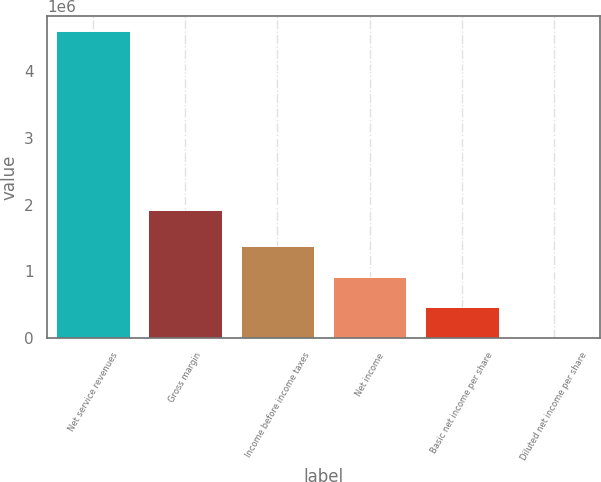Convert chart. <chart><loc_0><loc_0><loc_500><loc_500><bar_chart><fcel>Net service revenues<fcel>Gross margin<fcel>Income before income taxes<fcel>Net income<fcel>Basic net income per share<fcel>Diluted net income per share<nl><fcel>4.60055e+06<fcel>1.91357e+06<fcel>1.38017e+06<fcel>920112<fcel>460057<fcel>1.63<nl></chart> 